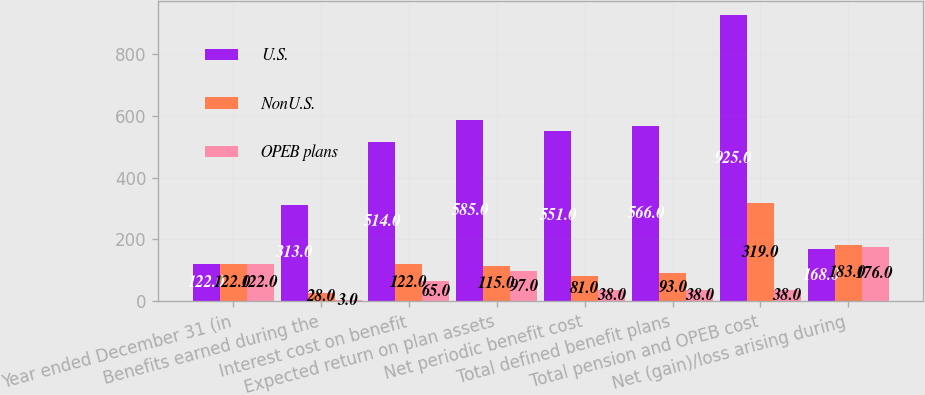Convert chart. <chart><loc_0><loc_0><loc_500><loc_500><stacked_bar_chart><ecel><fcel>Year ended December 31 (in<fcel>Benefits earned during the<fcel>Interest cost on benefit<fcel>Expected return on plan assets<fcel>Net periodic benefit cost<fcel>Total defined benefit plans<fcel>Total pension and OPEB cost<fcel>Net (gain)/loss arising during<nl><fcel>U.S.<fcel>122<fcel>313<fcel>514<fcel>585<fcel>551<fcel>566<fcel>925<fcel>168<nl><fcel>NonU.S.<fcel>122<fcel>28<fcel>122<fcel>115<fcel>81<fcel>93<fcel>319<fcel>183<nl><fcel>OPEB plans<fcel>122<fcel>3<fcel>65<fcel>97<fcel>38<fcel>38<fcel>38<fcel>176<nl></chart> 